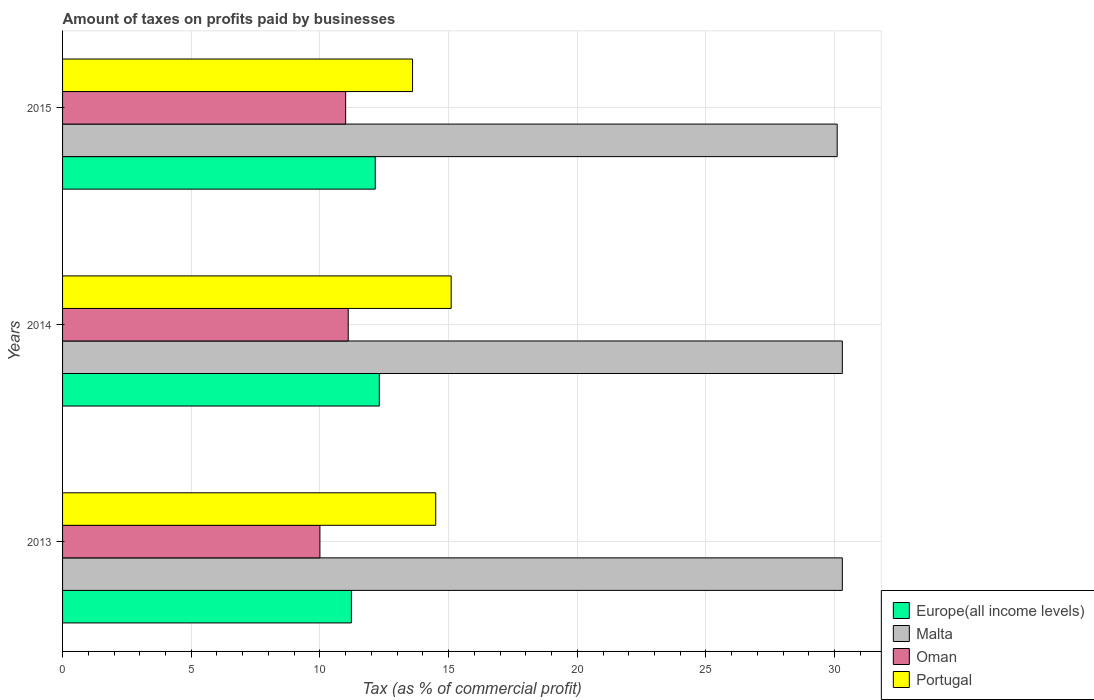How many groups of bars are there?
Give a very brief answer. 3. What is the label of the 2nd group of bars from the top?
Offer a terse response. 2014. In how many cases, is the number of bars for a given year not equal to the number of legend labels?
Offer a terse response. 0. What is the percentage of taxes paid by businesses in Oman in 2013?
Provide a succinct answer. 10. Across all years, what is the maximum percentage of taxes paid by businesses in Europe(all income levels)?
Your answer should be very brief. 12.31. In which year was the percentage of taxes paid by businesses in Malta maximum?
Make the answer very short. 2013. In which year was the percentage of taxes paid by businesses in Portugal minimum?
Ensure brevity in your answer.  2015. What is the total percentage of taxes paid by businesses in Europe(all income levels) in the graph?
Your answer should be very brief. 35.68. What is the difference between the percentage of taxes paid by businesses in Portugal in 2013 and that in 2014?
Keep it short and to the point. -0.6. What is the difference between the percentage of taxes paid by businesses in Malta in 2014 and the percentage of taxes paid by businesses in Europe(all income levels) in 2015?
Your answer should be compact. 18.15. What is the average percentage of taxes paid by businesses in Europe(all income levels) per year?
Give a very brief answer. 11.89. In the year 2013, what is the difference between the percentage of taxes paid by businesses in Malta and percentage of taxes paid by businesses in Oman?
Offer a terse response. 20.3. In how many years, is the percentage of taxes paid by businesses in Malta greater than 4 %?
Your answer should be very brief. 3. What is the ratio of the percentage of taxes paid by businesses in Europe(all income levels) in 2014 to that in 2015?
Provide a short and direct response. 1.01. Is the percentage of taxes paid by businesses in Oman in 2013 less than that in 2014?
Offer a terse response. Yes. What is the difference between the highest and the second highest percentage of taxes paid by businesses in Europe(all income levels)?
Offer a terse response. 0.16. What is the difference between the highest and the lowest percentage of taxes paid by businesses in Europe(all income levels)?
Your answer should be compact. 1.08. In how many years, is the percentage of taxes paid by businesses in Oman greater than the average percentage of taxes paid by businesses in Oman taken over all years?
Give a very brief answer. 2. What does the 2nd bar from the top in 2014 represents?
Ensure brevity in your answer.  Oman. What does the 3rd bar from the bottom in 2013 represents?
Give a very brief answer. Oman. How many years are there in the graph?
Provide a succinct answer. 3. Does the graph contain grids?
Make the answer very short. Yes. How many legend labels are there?
Provide a short and direct response. 4. How are the legend labels stacked?
Offer a terse response. Vertical. What is the title of the graph?
Offer a terse response. Amount of taxes on profits paid by businesses. What is the label or title of the X-axis?
Your answer should be compact. Tax (as % of commercial profit). What is the Tax (as % of commercial profit) of Europe(all income levels) in 2013?
Your response must be concise. 11.22. What is the Tax (as % of commercial profit) in Malta in 2013?
Make the answer very short. 30.3. What is the Tax (as % of commercial profit) in Europe(all income levels) in 2014?
Offer a very short reply. 12.31. What is the Tax (as % of commercial profit) in Malta in 2014?
Keep it short and to the point. 30.3. What is the Tax (as % of commercial profit) in Oman in 2014?
Your answer should be very brief. 11.1. What is the Tax (as % of commercial profit) in Portugal in 2014?
Make the answer very short. 15.1. What is the Tax (as % of commercial profit) in Europe(all income levels) in 2015?
Your answer should be very brief. 12.15. What is the Tax (as % of commercial profit) of Malta in 2015?
Provide a succinct answer. 30.1. What is the Tax (as % of commercial profit) in Portugal in 2015?
Provide a succinct answer. 13.6. Across all years, what is the maximum Tax (as % of commercial profit) of Europe(all income levels)?
Your answer should be very brief. 12.31. Across all years, what is the maximum Tax (as % of commercial profit) in Malta?
Your response must be concise. 30.3. Across all years, what is the maximum Tax (as % of commercial profit) in Portugal?
Provide a succinct answer. 15.1. Across all years, what is the minimum Tax (as % of commercial profit) of Europe(all income levels)?
Offer a very short reply. 11.22. Across all years, what is the minimum Tax (as % of commercial profit) in Malta?
Your answer should be very brief. 30.1. Across all years, what is the minimum Tax (as % of commercial profit) of Portugal?
Offer a very short reply. 13.6. What is the total Tax (as % of commercial profit) in Europe(all income levels) in the graph?
Provide a short and direct response. 35.68. What is the total Tax (as % of commercial profit) in Malta in the graph?
Your answer should be compact. 90.7. What is the total Tax (as % of commercial profit) of Oman in the graph?
Ensure brevity in your answer.  32.1. What is the total Tax (as % of commercial profit) in Portugal in the graph?
Your answer should be compact. 43.2. What is the difference between the Tax (as % of commercial profit) of Europe(all income levels) in 2013 and that in 2014?
Keep it short and to the point. -1.08. What is the difference between the Tax (as % of commercial profit) of Malta in 2013 and that in 2014?
Provide a short and direct response. 0. What is the difference between the Tax (as % of commercial profit) of Portugal in 2013 and that in 2014?
Ensure brevity in your answer.  -0.6. What is the difference between the Tax (as % of commercial profit) in Europe(all income levels) in 2013 and that in 2015?
Your answer should be compact. -0.93. What is the difference between the Tax (as % of commercial profit) of Malta in 2013 and that in 2015?
Make the answer very short. 0.2. What is the difference between the Tax (as % of commercial profit) of Oman in 2013 and that in 2015?
Offer a terse response. -1. What is the difference between the Tax (as % of commercial profit) of Europe(all income levels) in 2014 and that in 2015?
Your answer should be compact. 0.16. What is the difference between the Tax (as % of commercial profit) of Europe(all income levels) in 2013 and the Tax (as % of commercial profit) of Malta in 2014?
Provide a succinct answer. -19.08. What is the difference between the Tax (as % of commercial profit) in Europe(all income levels) in 2013 and the Tax (as % of commercial profit) in Oman in 2014?
Your response must be concise. 0.12. What is the difference between the Tax (as % of commercial profit) of Europe(all income levels) in 2013 and the Tax (as % of commercial profit) of Portugal in 2014?
Offer a terse response. -3.88. What is the difference between the Tax (as % of commercial profit) in Malta in 2013 and the Tax (as % of commercial profit) in Portugal in 2014?
Your answer should be compact. 15.2. What is the difference between the Tax (as % of commercial profit) of Europe(all income levels) in 2013 and the Tax (as % of commercial profit) of Malta in 2015?
Keep it short and to the point. -18.88. What is the difference between the Tax (as % of commercial profit) in Europe(all income levels) in 2013 and the Tax (as % of commercial profit) in Oman in 2015?
Your answer should be very brief. 0.22. What is the difference between the Tax (as % of commercial profit) of Europe(all income levels) in 2013 and the Tax (as % of commercial profit) of Portugal in 2015?
Offer a terse response. -2.38. What is the difference between the Tax (as % of commercial profit) in Malta in 2013 and the Tax (as % of commercial profit) in Oman in 2015?
Your answer should be very brief. 19.3. What is the difference between the Tax (as % of commercial profit) of Europe(all income levels) in 2014 and the Tax (as % of commercial profit) of Malta in 2015?
Provide a short and direct response. -17.79. What is the difference between the Tax (as % of commercial profit) in Europe(all income levels) in 2014 and the Tax (as % of commercial profit) in Oman in 2015?
Ensure brevity in your answer.  1.31. What is the difference between the Tax (as % of commercial profit) in Europe(all income levels) in 2014 and the Tax (as % of commercial profit) in Portugal in 2015?
Offer a terse response. -1.29. What is the difference between the Tax (as % of commercial profit) in Malta in 2014 and the Tax (as % of commercial profit) in Oman in 2015?
Provide a succinct answer. 19.3. What is the difference between the Tax (as % of commercial profit) of Malta in 2014 and the Tax (as % of commercial profit) of Portugal in 2015?
Provide a succinct answer. 16.7. What is the average Tax (as % of commercial profit) in Europe(all income levels) per year?
Make the answer very short. 11.89. What is the average Tax (as % of commercial profit) in Malta per year?
Offer a terse response. 30.23. What is the average Tax (as % of commercial profit) of Portugal per year?
Make the answer very short. 14.4. In the year 2013, what is the difference between the Tax (as % of commercial profit) of Europe(all income levels) and Tax (as % of commercial profit) of Malta?
Your response must be concise. -19.08. In the year 2013, what is the difference between the Tax (as % of commercial profit) in Europe(all income levels) and Tax (as % of commercial profit) in Oman?
Your answer should be compact. 1.22. In the year 2013, what is the difference between the Tax (as % of commercial profit) in Europe(all income levels) and Tax (as % of commercial profit) in Portugal?
Your answer should be very brief. -3.28. In the year 2013, what is the difference between the Tax (as % of commercial profit) in Malta and Tax (as % of commercial profit) in Oman?
Provide a succinct answer. 20.3. In the year 2014, what is the difference between the Tax (as % of commercial profit) in Europe(all income levels) and Tax (as % of commercial profit) in Malta?
Make the answer very short. -17.99. In the year 2014, what is the difference between the Tax (as % of commercial profit) in Europe(all income levels) and Tax (as % of commercial profit) in Oman?
Your answer should be compact. 1.21. In the year 2014, what is the difference between the Tax (as % of commercial profit) of Europe(all income levels) and Tax (as % of commercial profit) of Portugal?
Provide a short and direct response. -2.79. In the year 2014, what is the difference between the Tax (as % of commercial profit) of Malta and Tax (as % of commercial profit) of Oman?
Keep it short and to the point. 19.2. In the year 2014, what is the difference between the Tax (as % of commercial profit) of Malta and Tax (as % of commercial profit) of Portugal?
Offer a very short reply. 15.2. In the year 2014, what is the difference between the Tax (as % of commercial profit) in Oman and Tax (as % of commercial profit) in Portugal?
Your answer should be very brief. -4. In the year 2015, what is the difference between the Tax (as % of commercial profit) of Europe(all income levels) and Tax (as % of commercial profit) of Malta?
Your response must be concise. -17.95. In the year 2015, what is the difference between the Tax (as % of commercial profit) of Europe(all income levels) and Tax (as % of commercial profit) of Oman?
Provide a short and direct response. 1.15. In the year 2015, what is the difference between the Tax (as % of commercial profit) of Europe(all income levels) and Tax (as % of commercial profit) of Portugal?
Keep it short and to the point. -1.45. What is the ratio of the Tax (as % of commercial profit) in Europe(all income levels) in 2013 to that in 2014?
Offer a terse response. 0.91. What is the ratio of the Tax (as % of commercial profit) of Malta in 2013 to that in 2014?
Your answer should be compact. 1. What is the ratio of the Tax (as % of commercial profit) in Oman in 2013 to that in 2014?
Provide a short and direct response. 0.9. What is the ratio of the Tax (as % of commercial profit) in Portugal in 2013 to that in 2014?
Provide a succinct answer. 0.96. What is the ratio of the Tax (as % of commercial profit) in Europe(all income levels) in 2013 to that in 2015?
Offer a terse response. 0.92. What is the ratio of the Tax (as % of commercial profit) of Malta in 2013 to that in 2015?
Provide a succinct answer. 1.01. What is the ratio of the Tax (as % of commercial profit) in Oman in 2013 to that in 2015?
Offer a very short reply. 0.91. What is the ratio of the Tax (as % of commercial profit) of Portugal in 2013 to that in 2015?
Your answer should be very brief. 1.07. What is the ratio of the Tax (as % of commercial profit) of Malta in 2014 to that in 2015?
Give a very brief answer. 1.01. What is the ratio of the Tax (as % of commercial profit) in Oman in 2014 to that in 2015?
Ensure brevity in your answer.  1.01. What is the ratio of the Tax (as % of commercial profit) in Portugal in 2014 to that in 2015?
Offer a terse response. 1.11. What is the difference between the highest and the second highest Tax (as % of commercial profit) of Europe(all income levels)?
Offer a very short reply. 0.16. What is the difference between the highest and the second highest Tax (as % of commercial profit) in Oman?
Make the answer very short. 0.1. What is the difference between the highest and the second highest Tax (as % of commercial profit) in Portugal?
Give a very brief answer. 0.6. What is the difference between the highest and the lowest Tax (as % of commercial profit) in Europe(all income levels)?
Offer a terse response. 1.08. What is the difference between the highest and the lowest Tax (as % of commercial profit) of Malta?
Provide a short and direct response. 0.2. What is the difference between the highest and the lowest Tax (as % of commercial profit) of Oman?
Make the answer very short. 1.1. What is the difference between the highest and the lowest Tax (as % of commercial profit) in Portugal?
Ensure brevity in your answer.  1.5. 